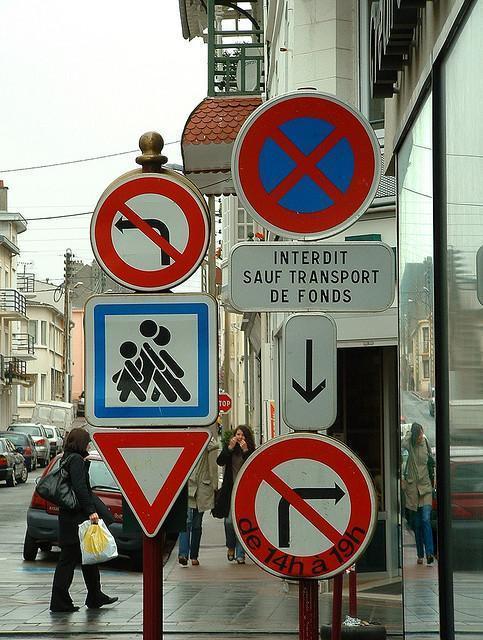How many signs are shown?
Give a very brief answer. 7. How many cars are there?
Give a very brief answer. 2. How many people are in the photo?
Give a very brief answer. 4. How many motorcycles are here?
Give a very brief answer. 0. 